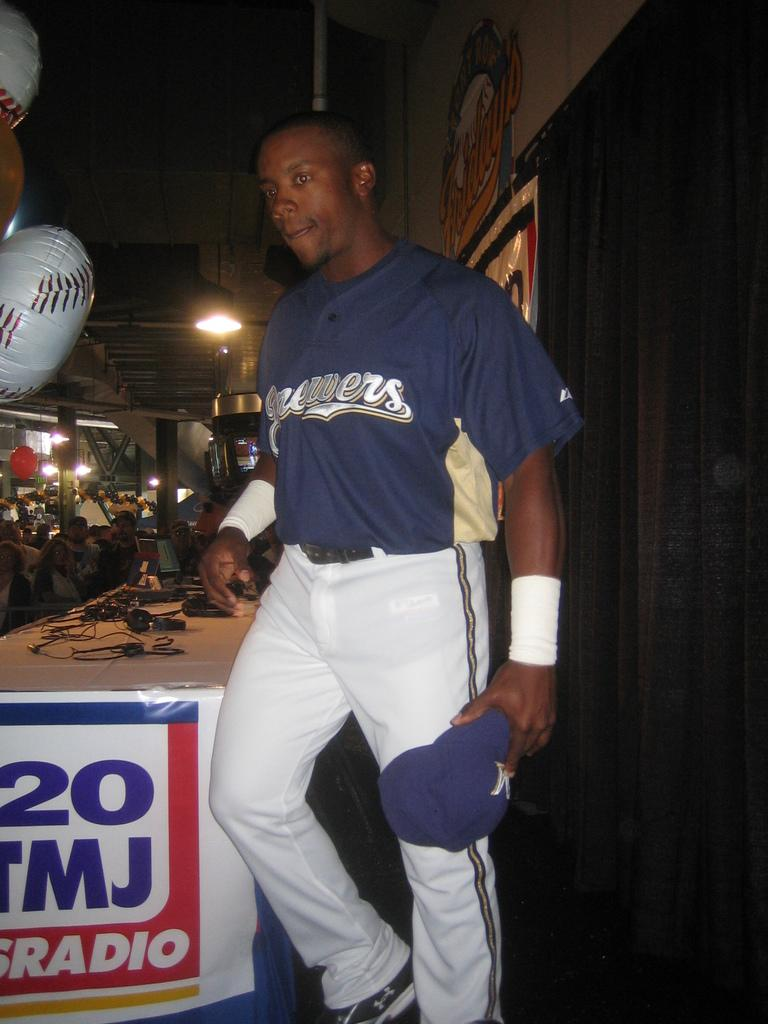<image>
Share a concise interpretation of the image provided. A baseball player with brewers written on his jersey. 